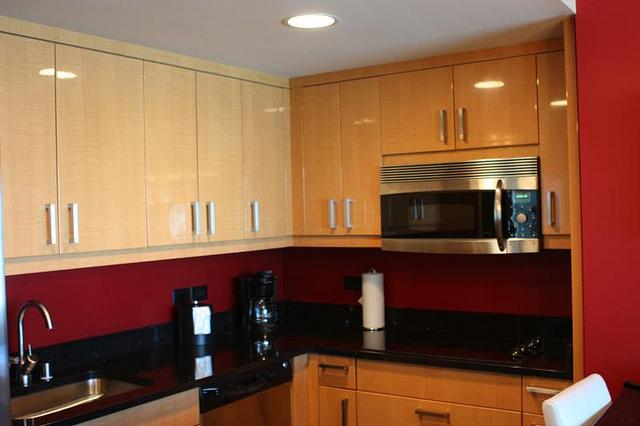What material is the sink made of?

Choices:
A) stainless steel
B) plastic
C) wood
D) porcelain stainless steel 